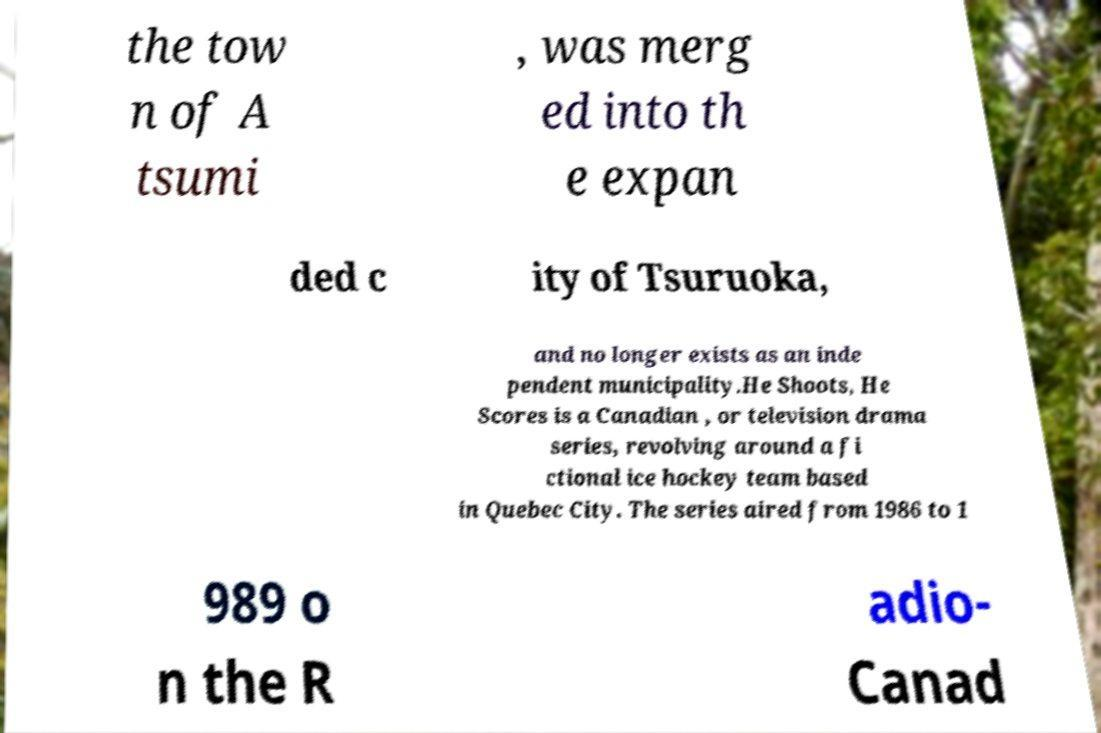Could you assist in decoding the text presented in this image and type it out clearly? the tow n of A tsumi , was merg ed into th e expan ded c ity of Tsuruoka, and no longer exists as an inde pendent municipality.He Shoots, He Scores is a Canadian , or television drama series, revolving around a fi ctional ice hockey team based in Quebec City. The series aired from 1986 to 1 989 o n the R adio- Canad 